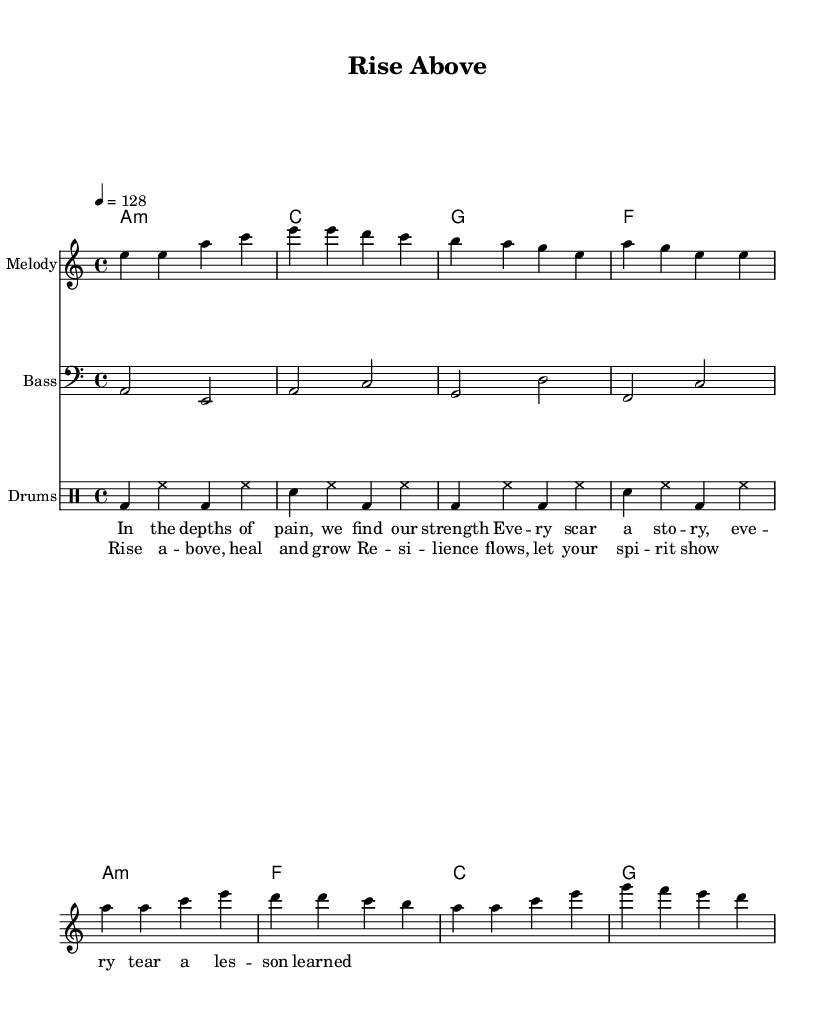What is the key signature of this music? The key signature is indicated by the "a" at the beginning, which shows that the music is in A minor. A minor has no sharps or flats.
Answer: A minor What is the time signature of this music? The time signature is shown by the "4/4" in the beginning, indicating that there are four beats in each measure and a quarter note gets one beat.
Answer: 4/4 What is the tempo marking of this music? The tempo is indicated as "4 = 128," which means there are 128 beats per minute. This is a moderate dance tempo.
Answer: 128 How many measures are in the melody section? By counting the groups of notes divided by vertical lines, there are a total of 8 measures in the melody section which consists of the verse and chorus parts.
Answer: 8 Which instrument plays the bass line? The bass line is written in the bass clef indicated by the symbol in the staff that shows lower pitches, typical for bass instruments.
Answer: Bass What is the primary theme expressed in the lyrics? The lyrics prominently feature themes of healing and resilience, as stated in the phrases “Rise above, heal and grow” and “Resilience flows, let your spirit show.”
Answer: Healing and resilience What type of drum patterns are used in this music? The drum patterns feature a combination of bass drum (bd), snare drum (sn), and hi-hat (hh) specified in the drum staff, typical for house music.
Answer: House music 